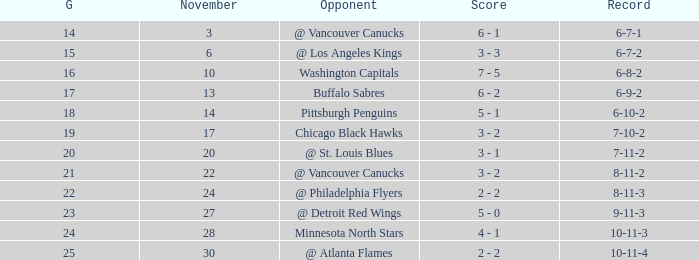Who is the opponent on november 24? @ Philadelphia Flyers. Could you parse the entire table as a dict? {'header': ['G', 'November', 'Opponent', 'Score', 'Record'], 'rows': [['14', '3', '@ Vancouver Canucks', '6 - 1', '6-7-1'], ['15', '6', '@ Los Angeles Kings', '3 - 3', '6-7-2'], ['16', '10', 'Washington Capitals', '7 - 5', '6-8-2'], ['17', '13', 'Buffalo Sabres', '6 - 2', '6-9-2'], ['18', '14', 'Pittsburgh Penguins', '5 - 1', '6-10-2'], ['19', '17', 'Chicago Black Hawks', '3 - 2', '7-10-2'], ['20', '20', '@ St. Louis Blues', '3 - 1', '7-11-2'], ['21', '22', '@ Vancouver Canucks', '3 - 2', '8-11-2'], ['22', '24', '@ Philadelphia Flyers', '2 - 2', '8-11-3'], ['23', '27', '@ Detroit Red Wings', '5 - 0', '9-11-3'], ['24', '28', 'Minnesota North Stars', '4 - 1', '10-11-3'], ['25', '30', '@ Atlanta Flames', '2 - 2', '10-11-4']]} 